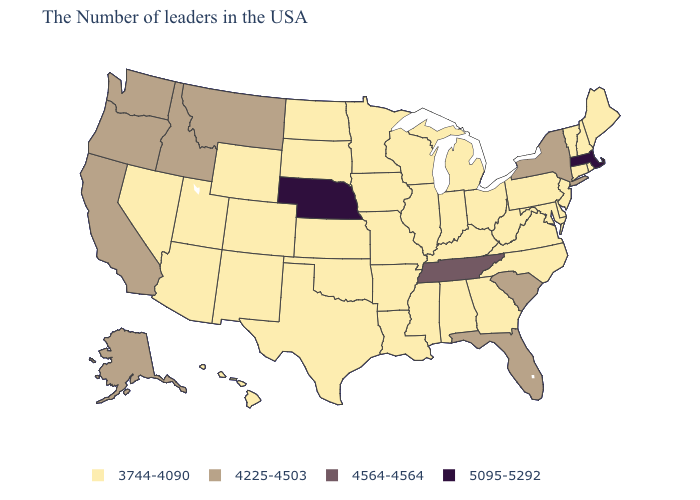Does the first symbol in the legend represent the smallest category?
Concise answer only. Yes. Name the states that have a value in the range 4225-4503?
Be succinct. New York, South Carolina, Florida, Montana, Idaho, California, Washington, Oregon, Alaska. Does Iowa have the same value as Washington?
Concise answer only. No. How many symbols are there in the legend?
Write a very short answer. 4. Does Connecticut have the same value as Kentucky?
Quick response, please. Yes. Does Arizona have the lowest value in the USA?
Short answer required. Yes. Name the states that have a value in the range 4225-4503?
Be succinct. New York, South Carolina, Florida, Montana, Idaho, California, Washington, Oregon, Alaska. Among the states that border Massachusetts , does New York have the highest value?
Write a very short answer. Yes. Name the states that have a value in the range 4225-4503?
Write a very short answer. New York, South Carolina, Florida, Montana, Idaho, California, Washington, Oregon, Alaska. Name the states that have a value in the range 4225-4503?
Concise answer only. New York, South Carolina, Florida, Montana, Idaho, California, Washington, Oregon, Alaska. What is the value of New York?
Write a very short answer. 4225-4503. Does the first symbol in the legend represent the smallest category?
Write a very short answer. Yes. Is the legend a continuous bar?
Concise answer only. No. Name the states that have a value in the range 3744-4090?
Concise answer only. Maine, Rhode Island, New Hampshire, Vermont, Connecticut, New Jersey, Delaware, Maryland, Pennsylvania, Virginia, North Carolina, West Virginia, Ohio, Georgia, Michigan, Kentucky, Indiana, Alabama, Wisconsin, Illinois, Mississippi, Louisiana, Missouri, Arkansas, Minnesota, Iowa, Kansas, Oklahoma, Texas, South Dakota, North Dakota, Wyoming, Colorado, New Mexico, Utah, Arizona, Nevada, Hawaii. What is the highest value in the South ?
Give a very brief answer. 4564-4564. 